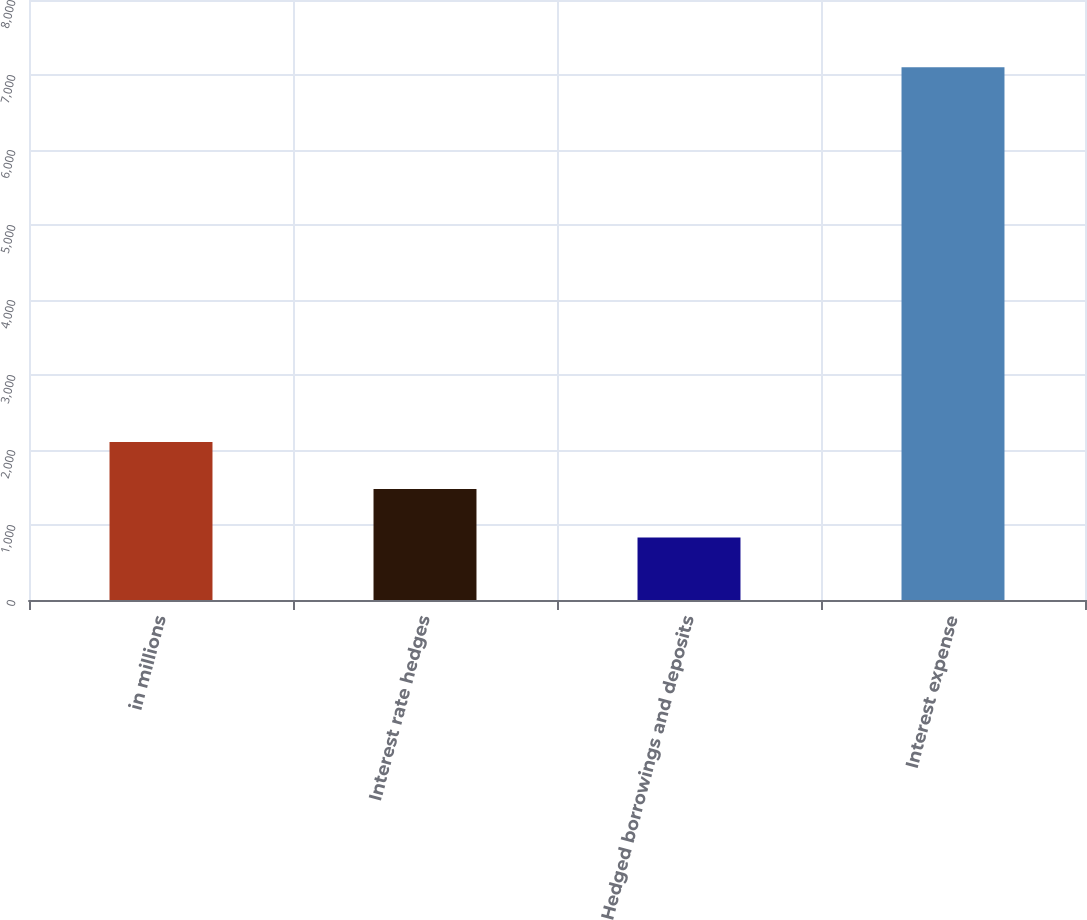Convert chart. <chart><loc_0><loc_0><loc_500><loc_500><bar_chart><fcel>in millions<fcel>Interest rate hedges<fcel>Hedged borrowings and deposits<fcel>Interest expense<nl><fcel>2107<fcel>1480<fcel>834<fcel>7104<nl></chart> 